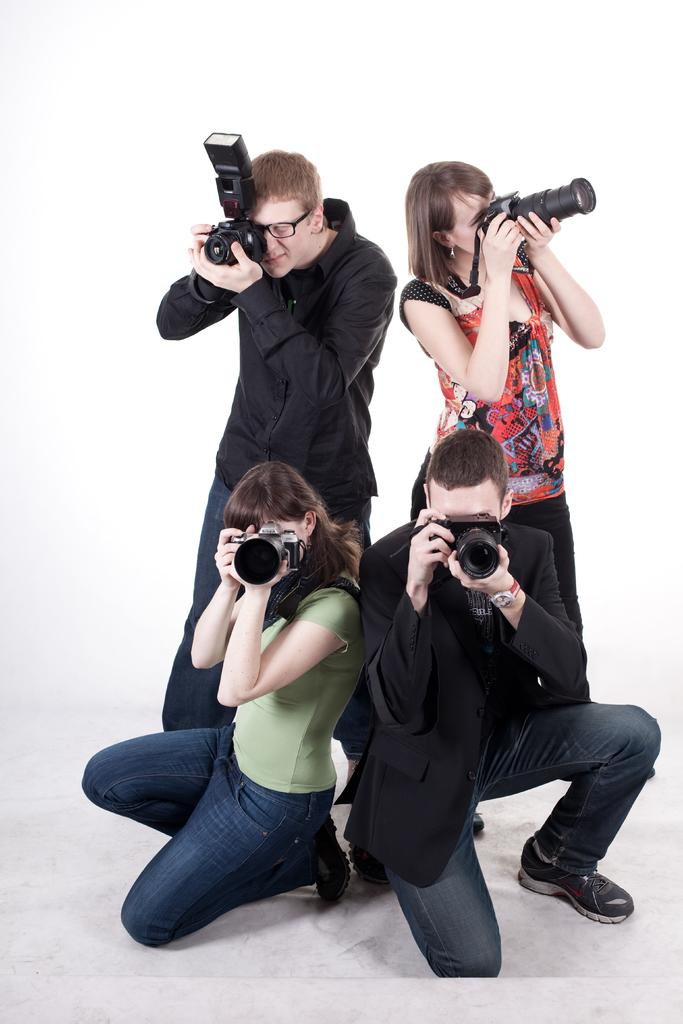How many people are present in the image? There are four people in the image. What are the people holding in their hands? The people are holding cameras. What is the color of the background in the image? The background of the image is white. Can you see a giraffe in the image? No, there is no giraffe present in the image. What type of heart is visible in the image? There is no heart visible in the image. 